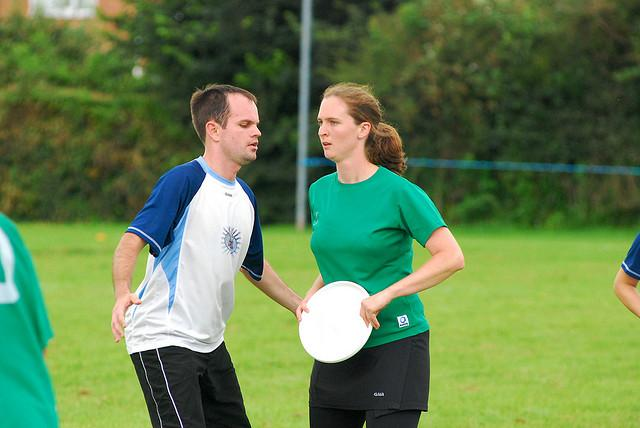The man in blue wants to do what to the frisbee holder? Please explain your reasoning. block her. His body language with his arms out indicate that he is trying to stop her from moving forward. 